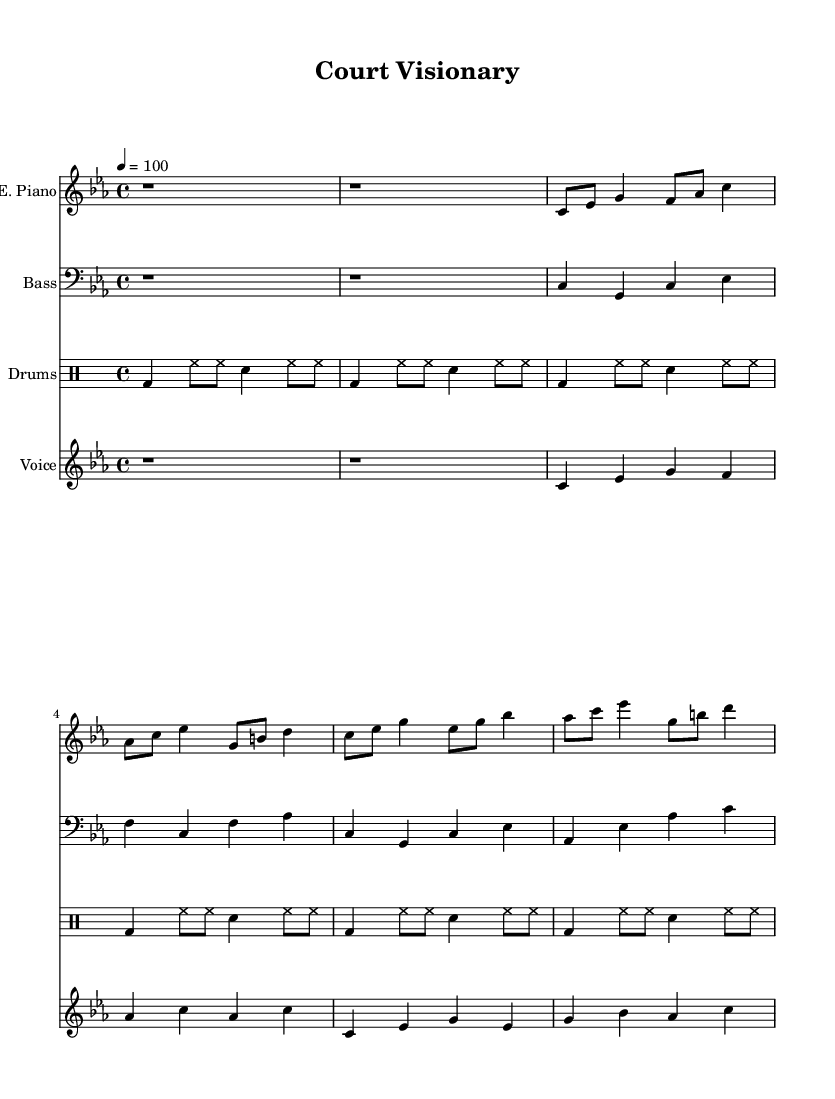What is the key signature of this music? The key signature is C minor, which has three flats (B♭, E♭, and A♭). I can identify this by looking at the beginning of the sheet music where the key is notated.
Answer: C minor What is the time signature of this music? The time signature is 4/4, meaning there are four beats in a measure, and the quarter note receives one beat. This can be seen at the beginning of the piece where the time signature is indicated.
Answer: 4/4 What is the tempo marking of this music? The tempo marking is 100 beats per minute (bpm), which indicates the speed of the performance. This is stated within the tempo indication at the beginning of the score.
Answer: 100 How many measures are present in the verse section? The verse section has 4 measures, as shown by counting the groups of beats from the beginning of the verse until the chorus starts.
Answer: 4 Which instrument plays the bass line? The bass line is played by the bass guitar, as noted in the staff labeling at the beginning of the bass part.
Answer: Bass guitar In the chorus, what chord does the melody start with? In the chorus, the melody starts with the C major chord, identifiable by looking at the notation in the voice part that begins on C.
Answer: C major What theme does the lyrics in this sheet music convey? The theme of the lyrics revolves around mental preparation and strategy, indicated by the phrases presented that focus on mental aspects in competitive contexts such as basketball.
Answer: Mental preparation 